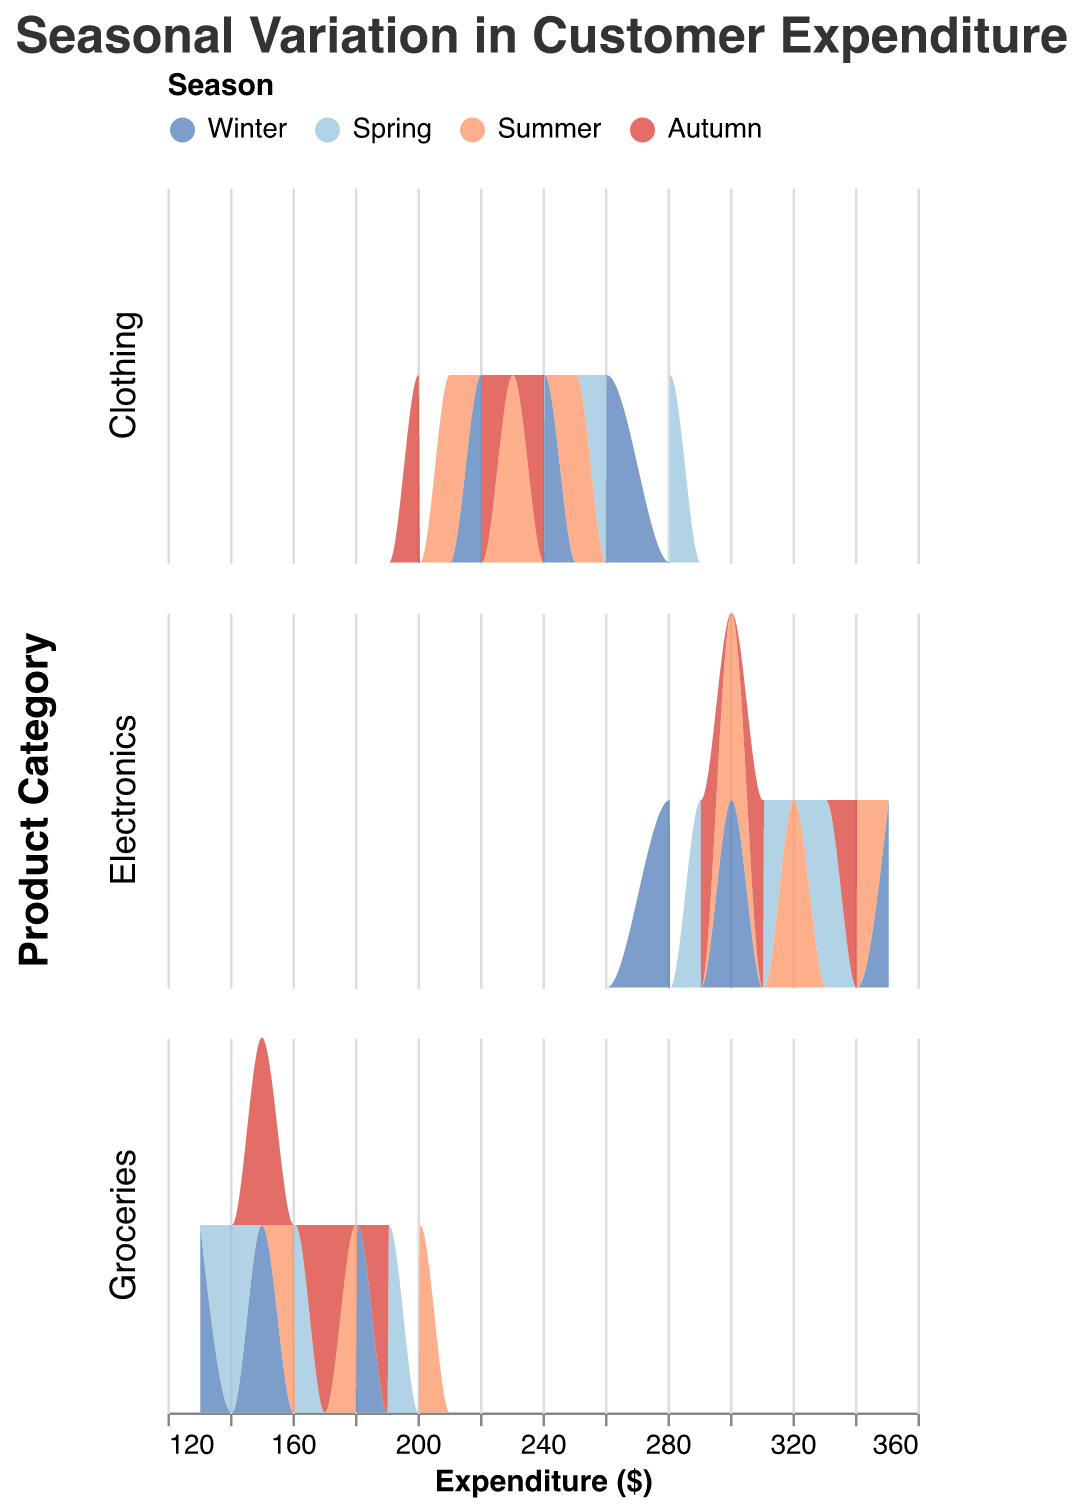What is the title of the figure? The title is typically displayed at the top of the plot, and it provides a brief description of what the figure represents. Here, it is "Seasonal Variation in Customer Expenditure".
Answer: Seasonal Variation in Customer Expenditure How many product categories are displayed in the figure? The figure uses rows to facet the data by product categories. There are three rows, each representing a different product category.
Answer: 3 Which color represents the Winter season in the plot? The legend at the top of the figure uses specific colors to represent different seasons. Winter is marked by a blue color that falls within the domain of ["#4575b4"].
Answer: Blue In which season is the expenditure for Clothing the highest? By observing the area under the curves for the Clothing category across different seasons, the season with the highest peak of expenditure can be identified.
Answer: Spring Compare the expenditure patterns for Electronics between Winter and Summer. Which season shows a higher peak expenditure? Look at the density plots for Electronics in Winter and Summer. Winter's peak is lower compared to the higher peak expenditure in Summer.
Answer: Summer Which product category shows the least variation in customer expenditure across seasons? The variation can be detected by comparing the spread of distributions in each product category. Groceries show the least variation as the distributions are similar across all seasons.
Answer: Groceries What is the typical expenditure range for Electronics in Autumn? Refer to the width of the distribution curve for Electronics in Autumn. The range is approximately from 290 to 340 dollars.
Answer: 290 - 340 dollars Which season has the smallest count of high expenditure in Groceries? Identify the season with the least density in the higher expenditure region for Groceries. Autumn has a smaller count in the highest expenditure range compared to other seasons.
Answer: Autumn How does the distribution for Clothing in Summer compare to Spring? Compare the shape and height of the density plots for Clothing between Summer and Spring. Summer has a flatter distribution with lower peak, whereas Spring shows a higher and narrower peak.
Answer: Spring Are the expenditures in Groceries more evenly distributed in Winter or Summer? Examine the distribution of expenditures for Groceries. Winter shows a slightly more even spread across expenditure ranges while Summer has a more pronounced peak, indicating less even distribution.
Answer: Winter 